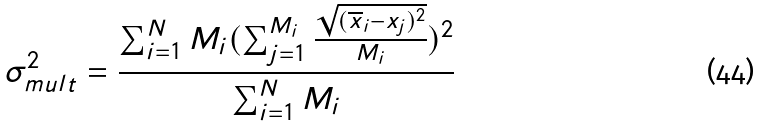Convert formula to latex. <formula><loc_0><loc_0><loc_500><loc_500>\sigma _ { m u l t } ^ { 2 } = \frac { \sum _ { i = 1 } ^ { N } M _ { i } ( \sum _ { j = 1 } ^ { M _ { i } } \frac { \sqrt { ( \overline { x } _ { i } - x _ { j } ) ^ { 2 } } } { M _ { i } } ) ^ { 2 } } { \sum _ { i = 1 } ^ { N } M _ { i } }</formula> 